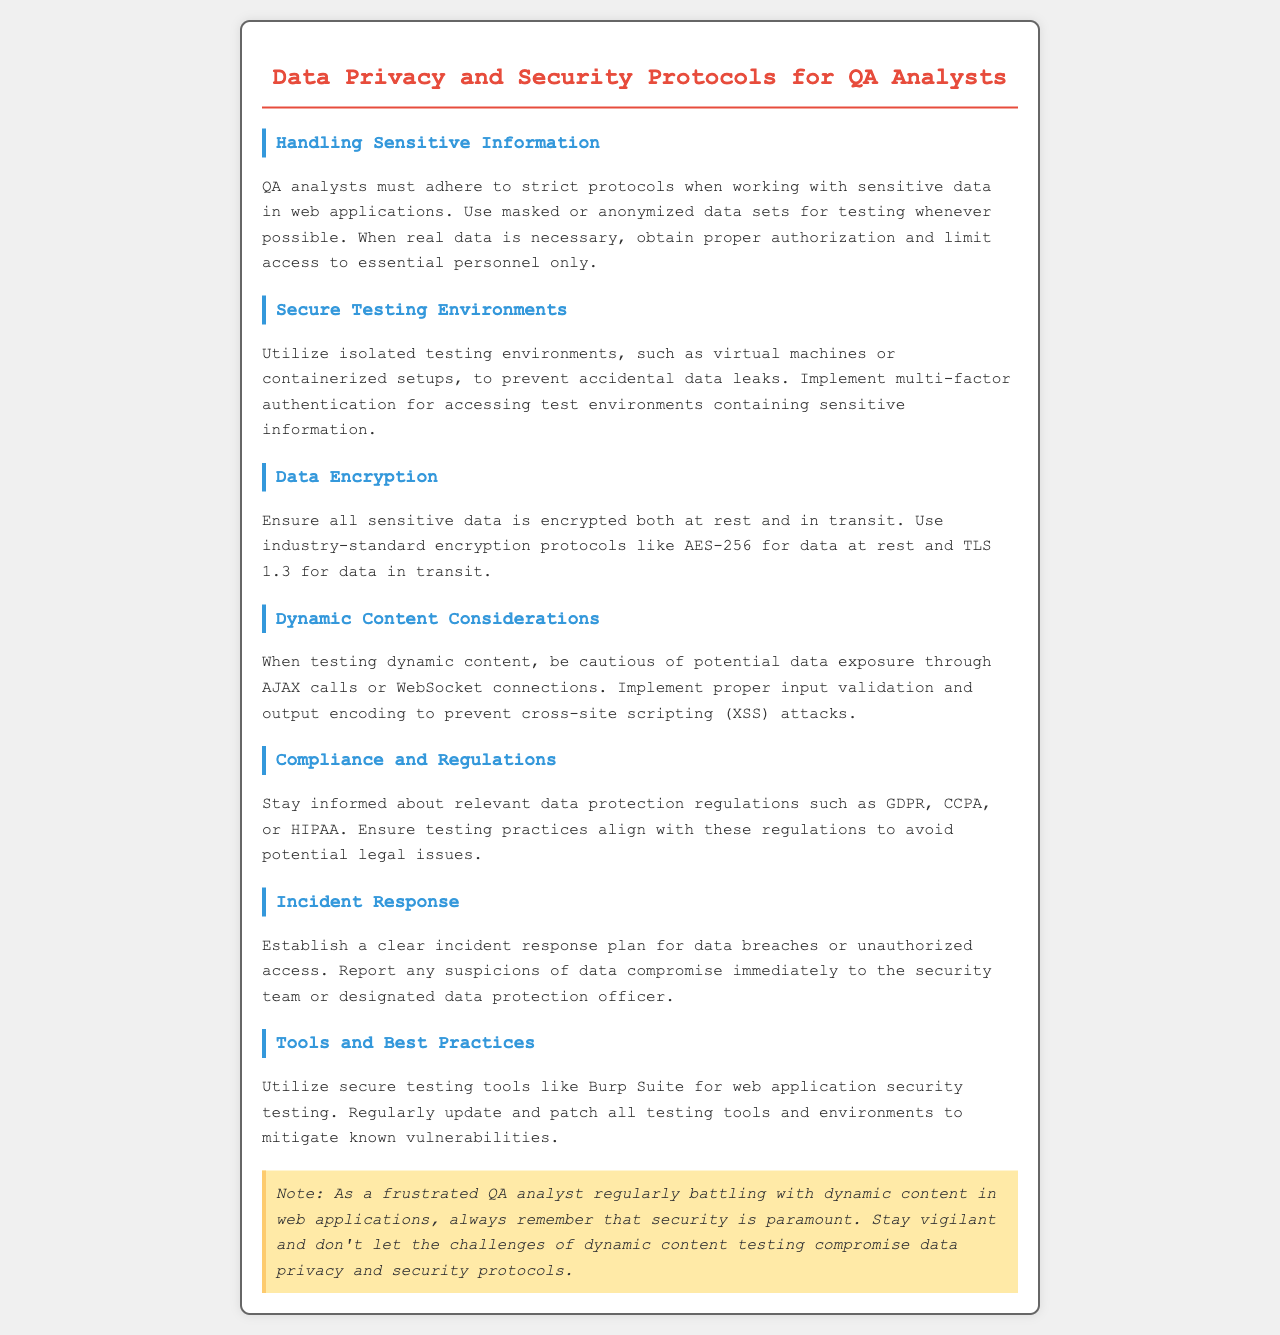What should QA analysts use for testing whenever possible? The document states that QA analysts should use masked or anonymized data sets for testing whenever possible.
Answer: Masked or anonymized data sets What is the minimum encryption standard suggested for data at rest? The document specifies using industry-standard encryption protocols like AES-256 for data at rest.
Answer: AES-256 Which authentication method is recommended for test environments? The document suggests implementing multi-factor authentication for accessing test environments containing sensitive information.
Answer: Multi-factor authentication What regularity should QA analysts stay informed about? The document mentions that QA analysts should stay informed about relevant data protection regulations.
Answer: Data protection regulations What two types of attacks should be prevented when testing dynamic content? The document highlights the necessity to implement proper input validation and output encoding to prevent cross-site scripting (XSS) attacks.
Answer: Cross-site scripting (XSS) What is necessary before using real data for testing? The document states that proper authorization is needed before using real data for testing.
Answer: Proper authorization When should any suspicions of data compromise be reported? QA analysts should report any suspicions of data compromise immediately according to the document.
Answer: Immediately What tool is recommended for web application security testing? The document suggests utilizing secure testing tools like Burp Suite for web application security testing.
Answer: Burp Suite 